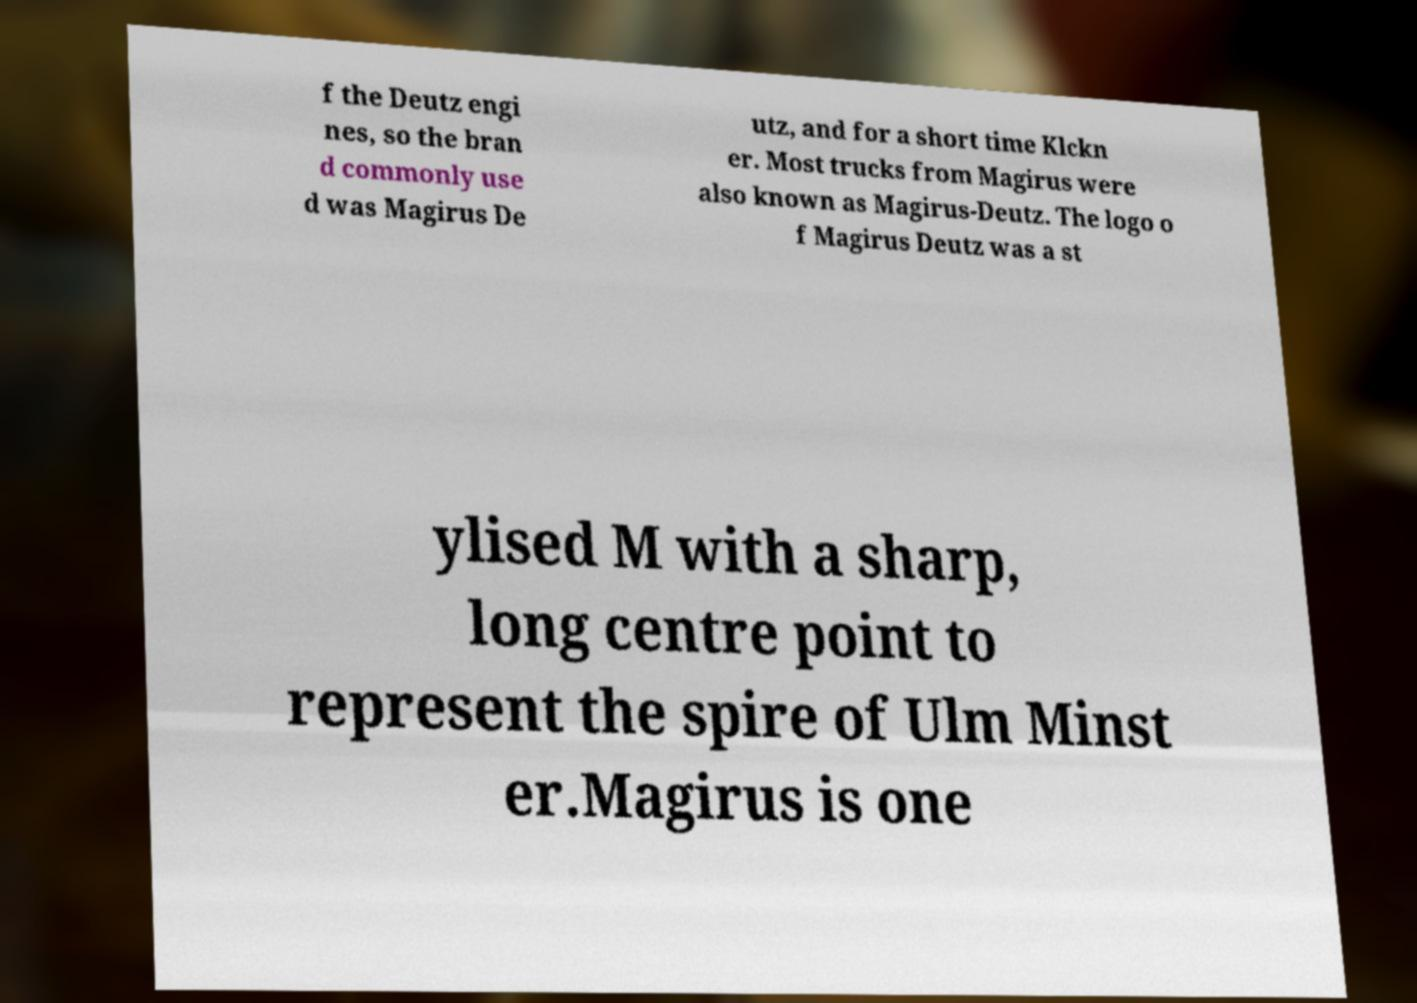Please identify and transcribe the text found in this image. f the Deutz engi nes, so the bran d commonly use d was Magirus De utz, and for a short time Klckn er. Most trucks from Magirus were also known as Magirus-Deutz. The logo o f Magirus Deutz was a st ylised M with a sharp, long centre point to represent the spire of Ulm Minst er.Magirus is one 